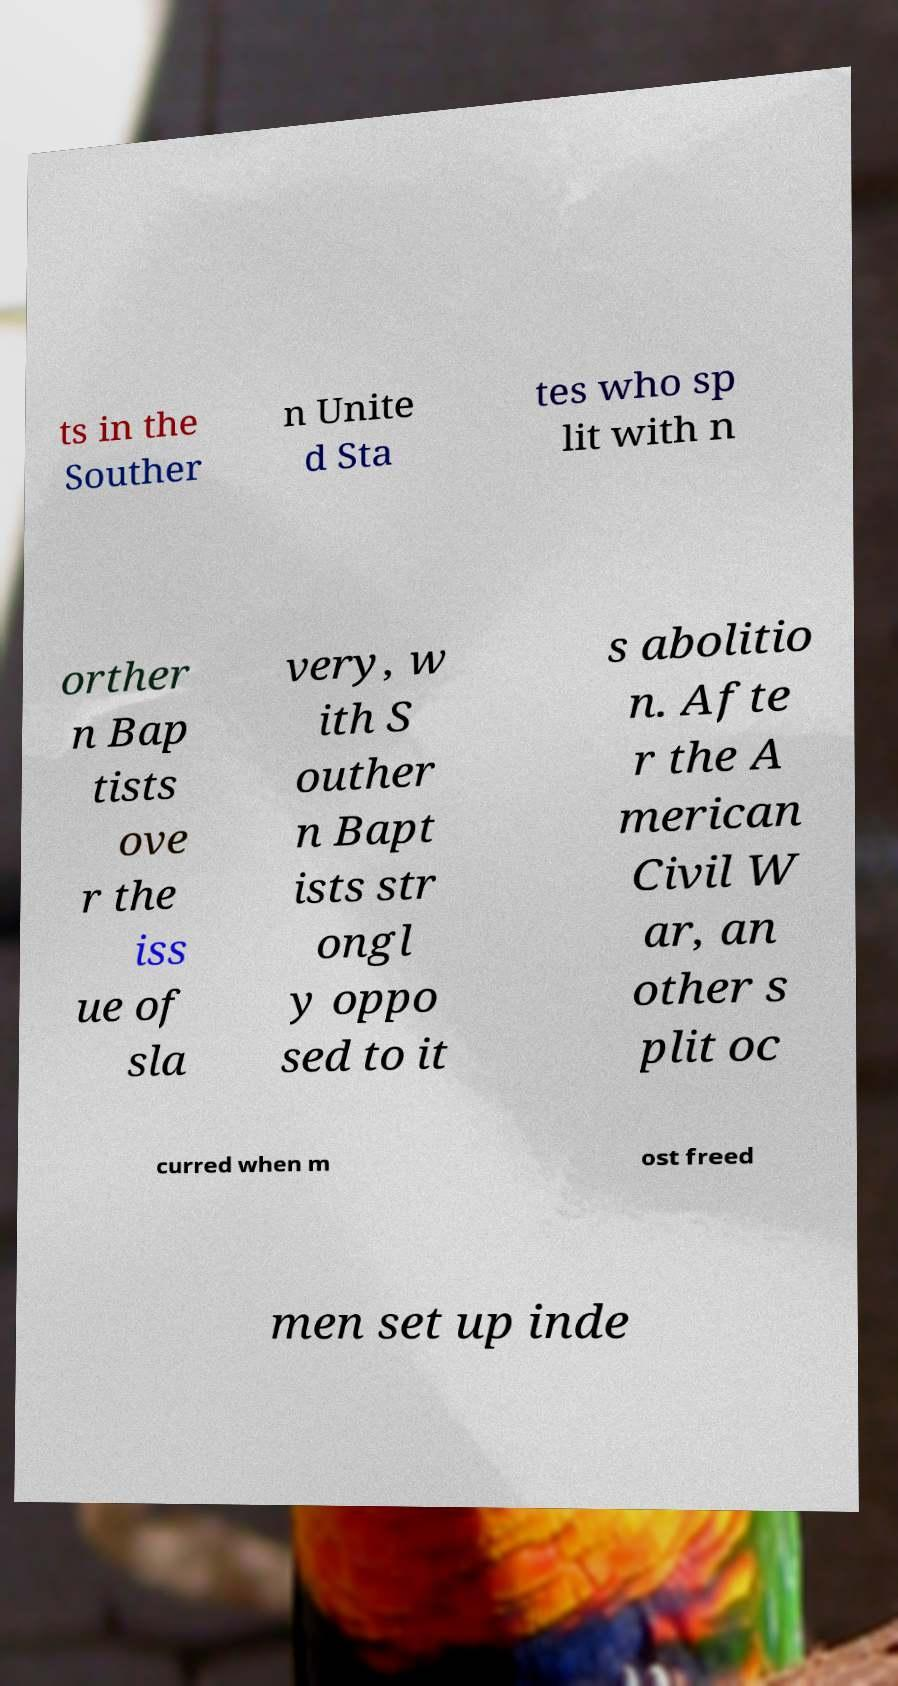I need the written content from this picture converted into text. Can you do that? ts in the Souther n Unite d Sta tes who sp lit with n orther n Bap tists ove r the iss ue of sla very, w ith S outher n Bapt ists str ongl y oppo sed to it s abolitio n. Afte r the A merican Civil W ar, an other s plit oc curred when m ost freed men set up inde 